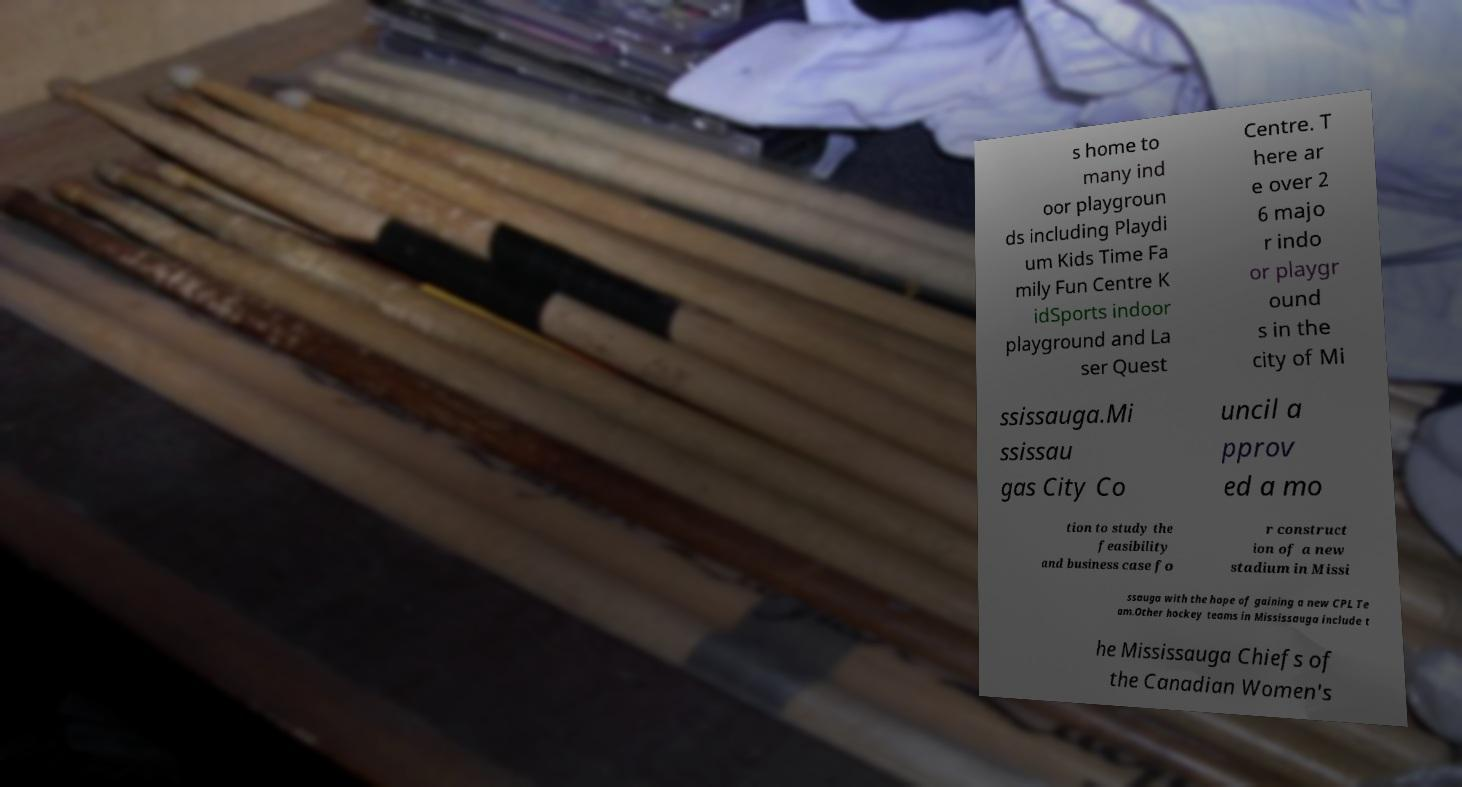Please read and relay the text visible in this image. What does it say? s home to many ind oor playgroun ds including Playdi um Kids Time Fa mily Fun Centre K idSports indoor playground and La ser Quest Centre. T here ar e over 2 6 majo r indo or playgr ound s in the city of Mi ssissauga.Mi ssissau gas City Co uncil a pprov ed a mo tion to study the feasibility and business case fo r construct ion of a new stadium in Missi ssauga with the hope of gaining a new CPL Te am.Other hockey teams in Mississauga include t he Mississauga Chiefs of the Canadian Women's 